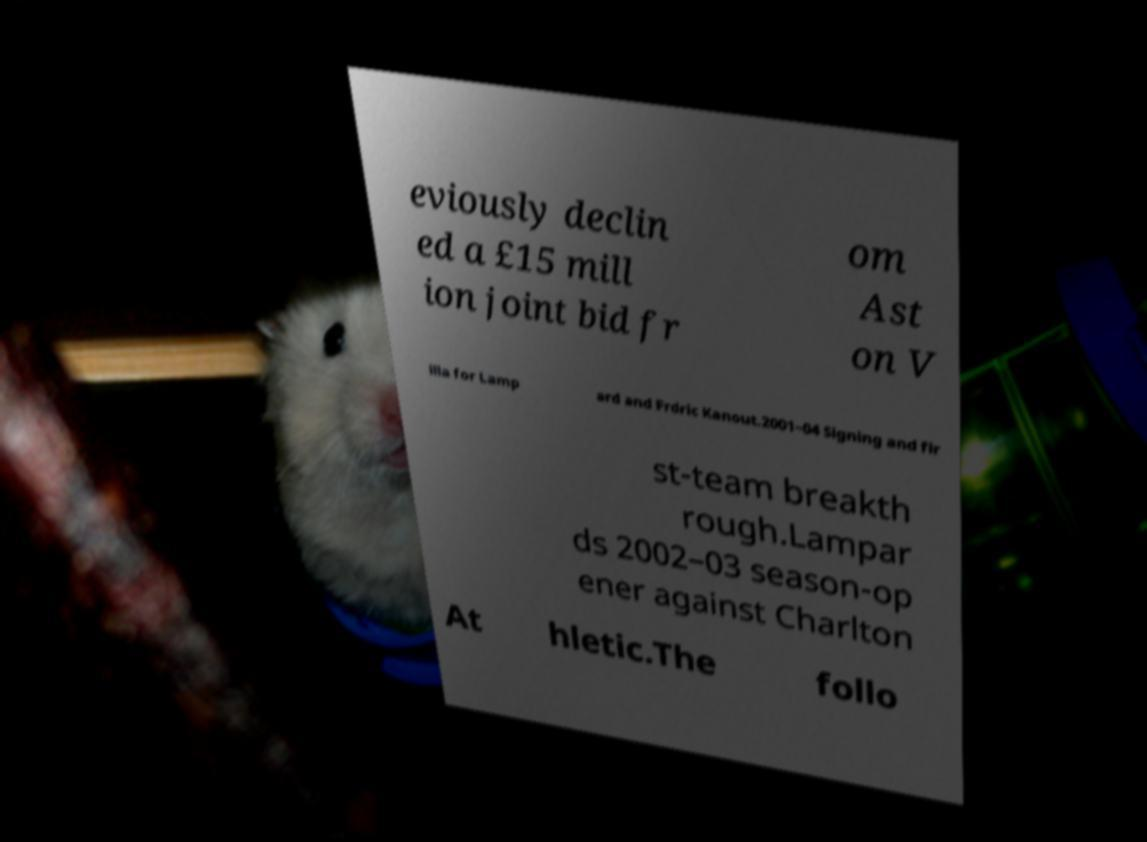Please identify and transcribe the text found in this image. eviously declin ed a £15 mill ion joint bid fr om Ast on V illa for Lamp ard and Frdric Kanout.2001–04 Signing and fir st-team breakth rough.Lampar ds 2002–03 season-op ener against Charlton At hletic.The follo 